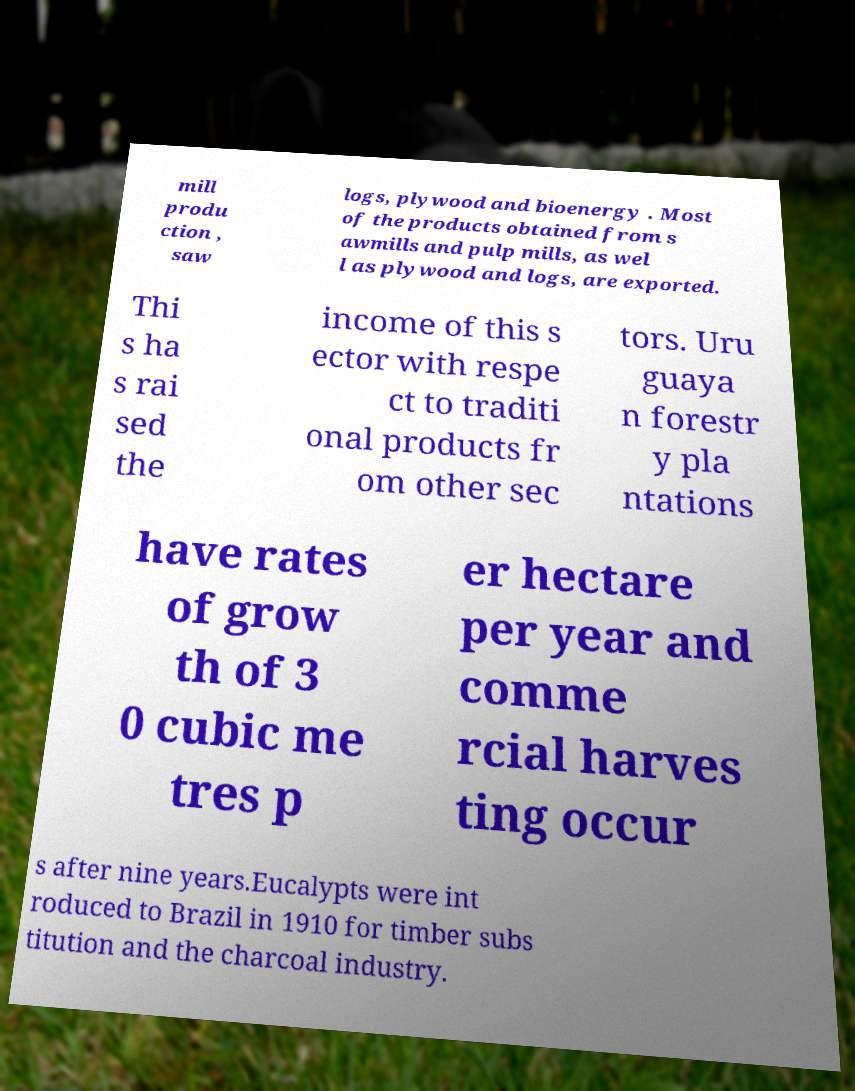I need the written content from this picture converted into text. Can you do that? mill produ ction , saw logs, plywood and bioenergy . Most of the products obtained from s awmills and pulp mills, as wel l as plywood and logs, are exported. Thi s ha s rai sed the income of this s ector with respe ct to traditi onal products fr om other sec tors. Uru guaya n forestr y pla ntations have rates of grow th of 3 0 cubic me tres p er hectare per year and comme rcial harves ting occur s after nine years.Eucalypts were int roduced to Brazil in 1910 for timber subs titution and the charcoal industry. 